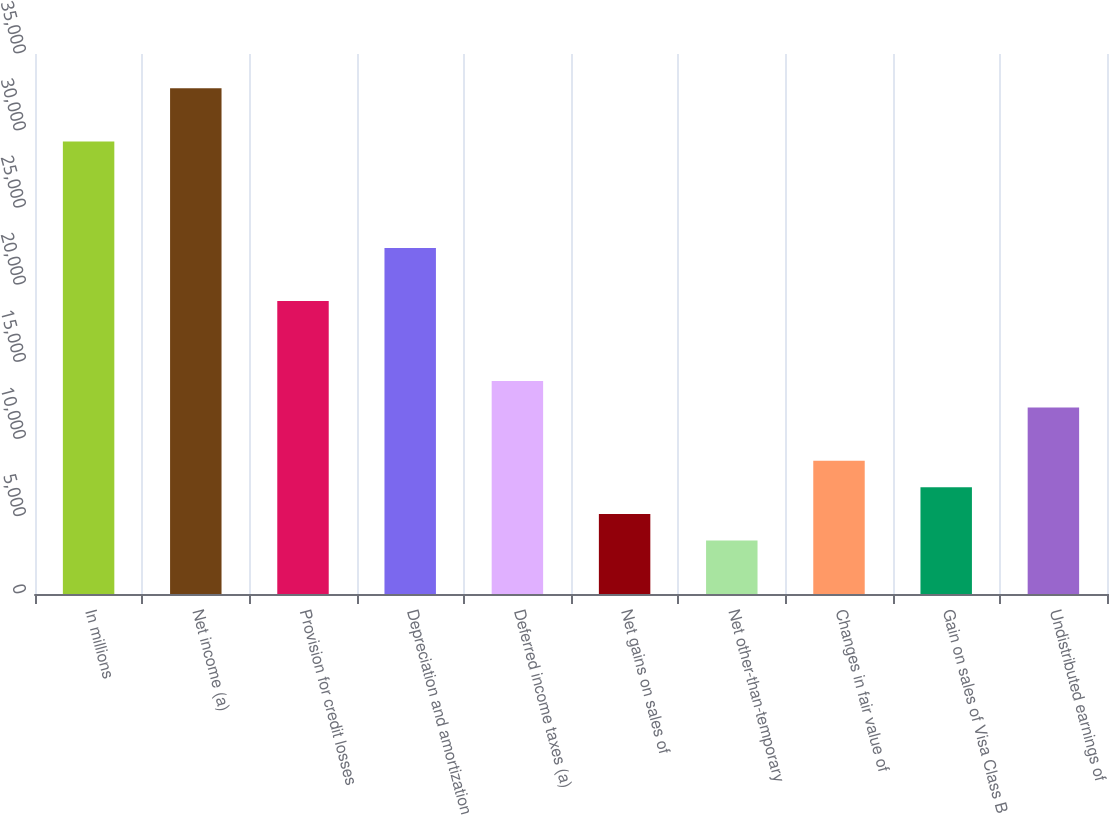Convert chart to OTSL. <chart><loc_0><loc_0><loc_500><loc_500><bar_chart><fcel>In millions<fcel>Net income (a)<fcel>Provision for credit losses<fcel>Depreciation and amortization<fcel>Deferred income taxes (a)<fcel>Net gains on sales of<fcel>Net other-than-temporary<fcel>Changes in fair value of<fcel>Gain on sales of Visa Class B<fcel>Undistributed earnings of<nl><fcel>29331.1<fcel>32779.7<fcel>18985.3<fcel>22433.9<fcel>13812.4<fcel>5190.9<fcel>3466.6<fcel>8639.5<fcel>6915.2<fcel>12088.1<nl></chart> 